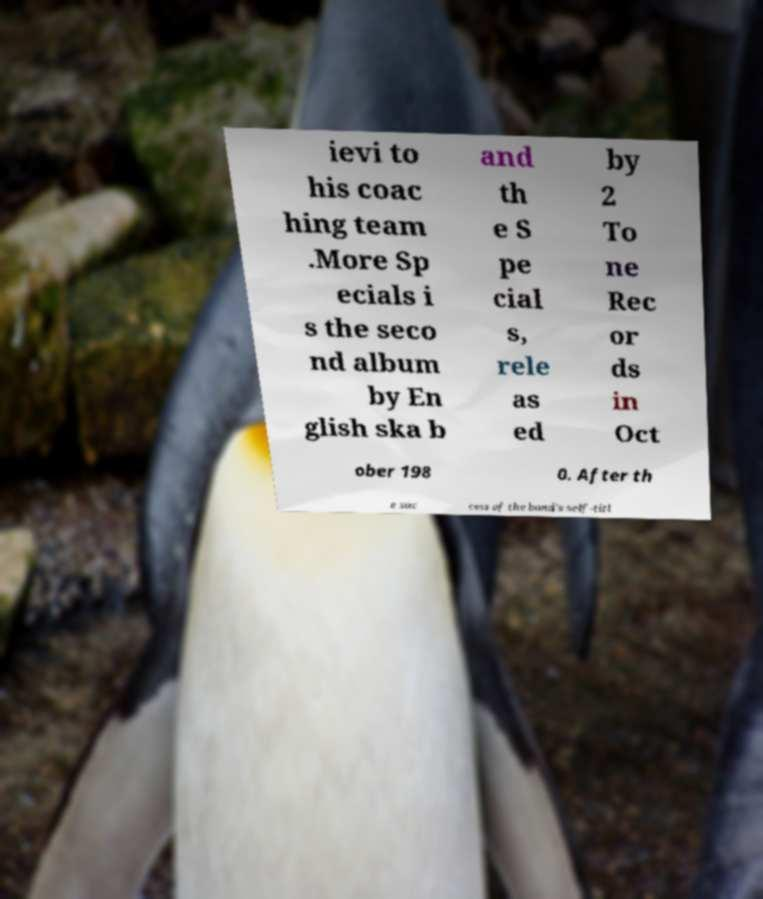Can you read and provide the text displayed in the image?This photo seems to have some interesting text. Can you extract and type it out for me? ievi to his coac hing team .More Sp ecials i s the seco nd album by En glish ska b and th e S pe cial s, rele as ed by 2 To ne Rec or ds in Oct ober 198 0. After th e suc cess of the band's self-titl 